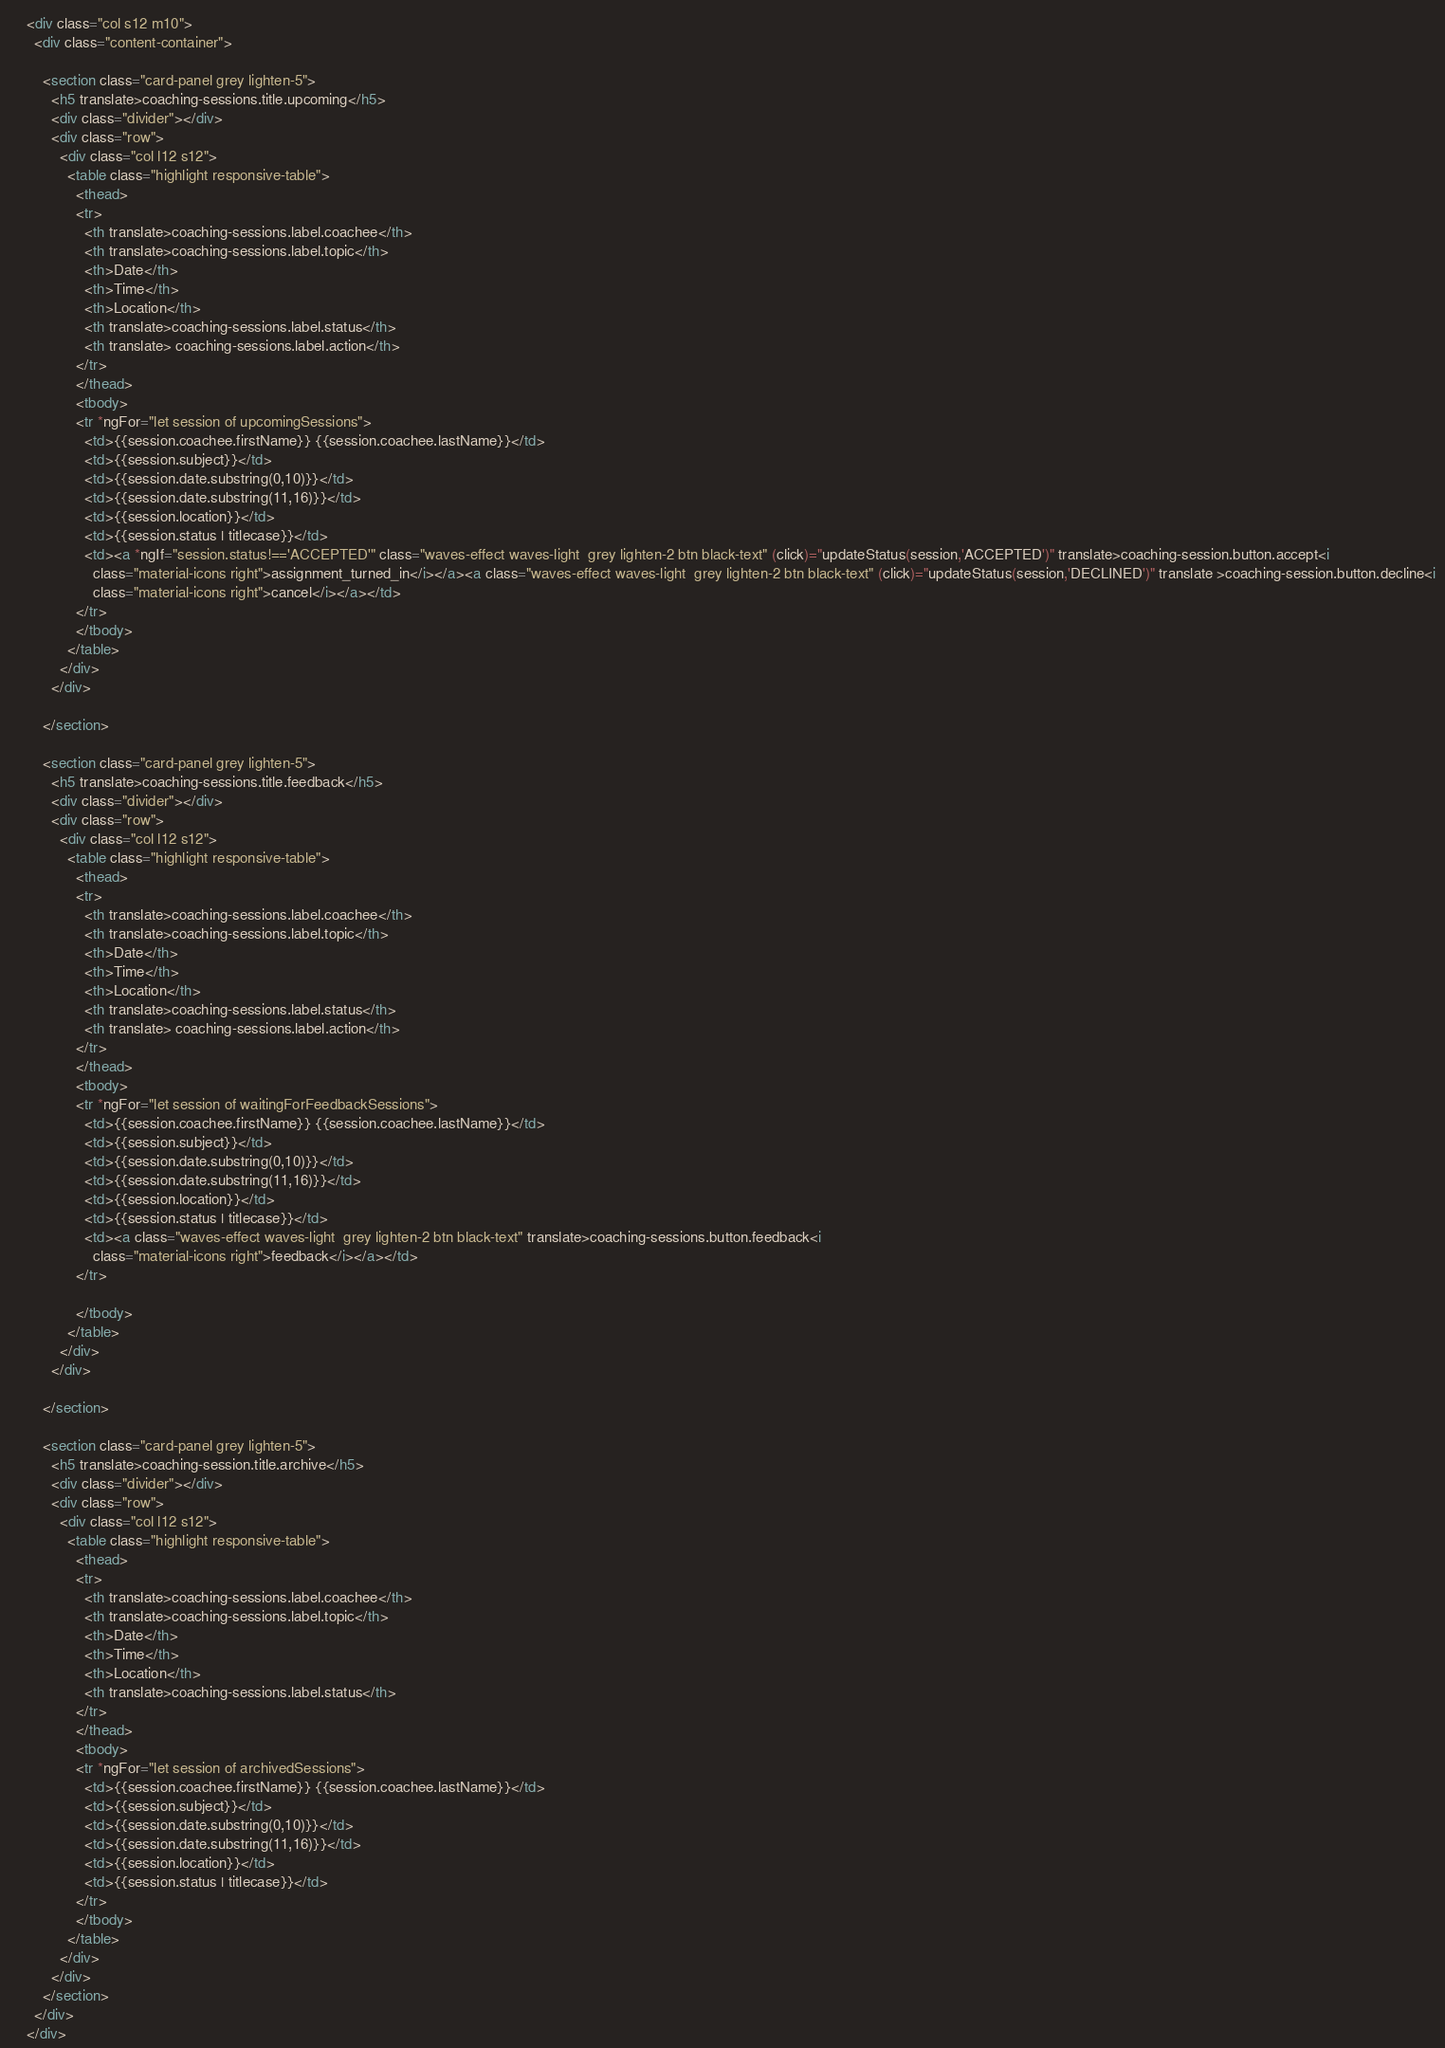<code> <loc_0><loc_0><loc_500><loc_500><_HTML_>

    <div class="col s12 m10">
      <div class="content-container">

        <section class="card-panel grey lighten-5">
          <h5 translate>coaching-sessions.title.upcoming</h5>
          <div class="divider"></div>
          <div class="row">
            <div class="col l12 s12">
              <table class="highlight responsive-table">
                <thead>
                <tr>
                  <th translate>coaching-sessions.label.coachee</th>
                  <th translate>coaching-sessions.label.topic</th>
                  <th>Date</th>
                  <th>Time</th>
                  <th>Location</th>
                  <th translate>coaching-sessions.label.status</th>
                  <th translate> coaching-sessions.label.action</th>
                </tr>
                </thead>
                <tbody>
                <tr *ngFor="let session of upcomingSessions">
                  <td>{{session.coachee.firstName}} {{session.coachee.lastName}}</td>
                  <td>{{session.subject}}</td>
                  <td>{{session.date.substring(0,10)}}</td>
                  <td>{{session.date.substring(11,16)}}</td>
                  <td>{{session.location}}</td>
                  <td>{{session.status | titlecase}}</td>
                  <td><a *ngIf="session.status!=='ACCEPTED'" class="waves-effect waves-light  grey lighten-2 btn black-text" (click)="updateStatus(session,'ACCEPTED')" translate>coaching-session.button.accept<i
                    class="material-icons right">assignment_turned_in</i></a><a class="waves-effect waves-light  grey lighten-2 btn black-text" (click)="updateStatus(session,'DECLINED')" translate >coaching-session.button.decline<i
                    class="material-icons right">cancel</i></a></td>
                </tr>
                </tbody>
              </table>
            </div>
          </div>

        </section>

        <section class="card-panel grey lighten-5">
          <h5 translate>coaching-sessions.title.feedback</h5>
          <div class="divider"></div>
          <div class="row">
            <div class="col l12 s12">
              <table class="highlight responsive-table">
                <thead>
                <tr>
                  <th translate>coaching-sessions.label.coachee</th>
                  <th translate>coaching-sessions.label.topic</th>
                  <th>Date</th>
                  <th>Time</th>
                  <th>Location</th>
                  <th translate>coaching-sessions.label.status</th>
                  <th translate> coaching-sessions.label.action</th>
                </tr>
                </thead>
                <tbody>
                <tr *ngFor="let session of waitingForFeedbackSessions">
                  <td>{{session.coachee.firstName}} {{session.coachee.lastName}}</td>
                  <td>{{session.subject}}</td>
                  <td>{{session.date.substring(0,10)}}</td>
                  <td>{{session.date.substring(11,16)}}</td>
                  <td>{{session.location}}</td>
                  <td>{{session.status | titlecase}}</td>
                  <td><a class="waves-effect waves-light  grey lighten-2 btn black-text" translate>coaching-sessions.button.feedback<i
                    class="material-icons right">feedback</i></a></td>
                </tr>

                </tbody>
              </table>
            </div>
          </div>

        </section>

        <section class="card-panel grey lighten-5">
          <h5 translate>coaching-session.title.archive</h5>
          <div class="divider"></div>
          <div class="row">
            <div class="col l12 s12">
              <table class="highlight responsive-table">
                <thead>
                <tr>
                  <th translate>coaching-sessions.label.coachee</th>
                  <th translate>coaching-sessions.label.topic</th>
                  <th>Date</th>
                  <th>Time</th>
                  <th>Location</th>
                  <th translate>coaching-sessions.label.status</th>
                </tr>
                </thead>
                <tbody>
                <tr *ngFor="let session of archivedSessions">
                  <td>{{session.coachee.firstName}} {{session.coachee.lastName}}</td>
                  <td>{{session.subject}}</td>
                  <td>{{session.date.substring(0,10)}}</td>
                  <td>{{session.date.substring(11,16)}}</td>
                  <td>{{session.location}}</td>
                  <td>{{session.status | titlecase}}</td>
                </tr>
                </tbody>
              </table>
            </div>
          </div>
        </section>
      </div>
    </div>

</code> 